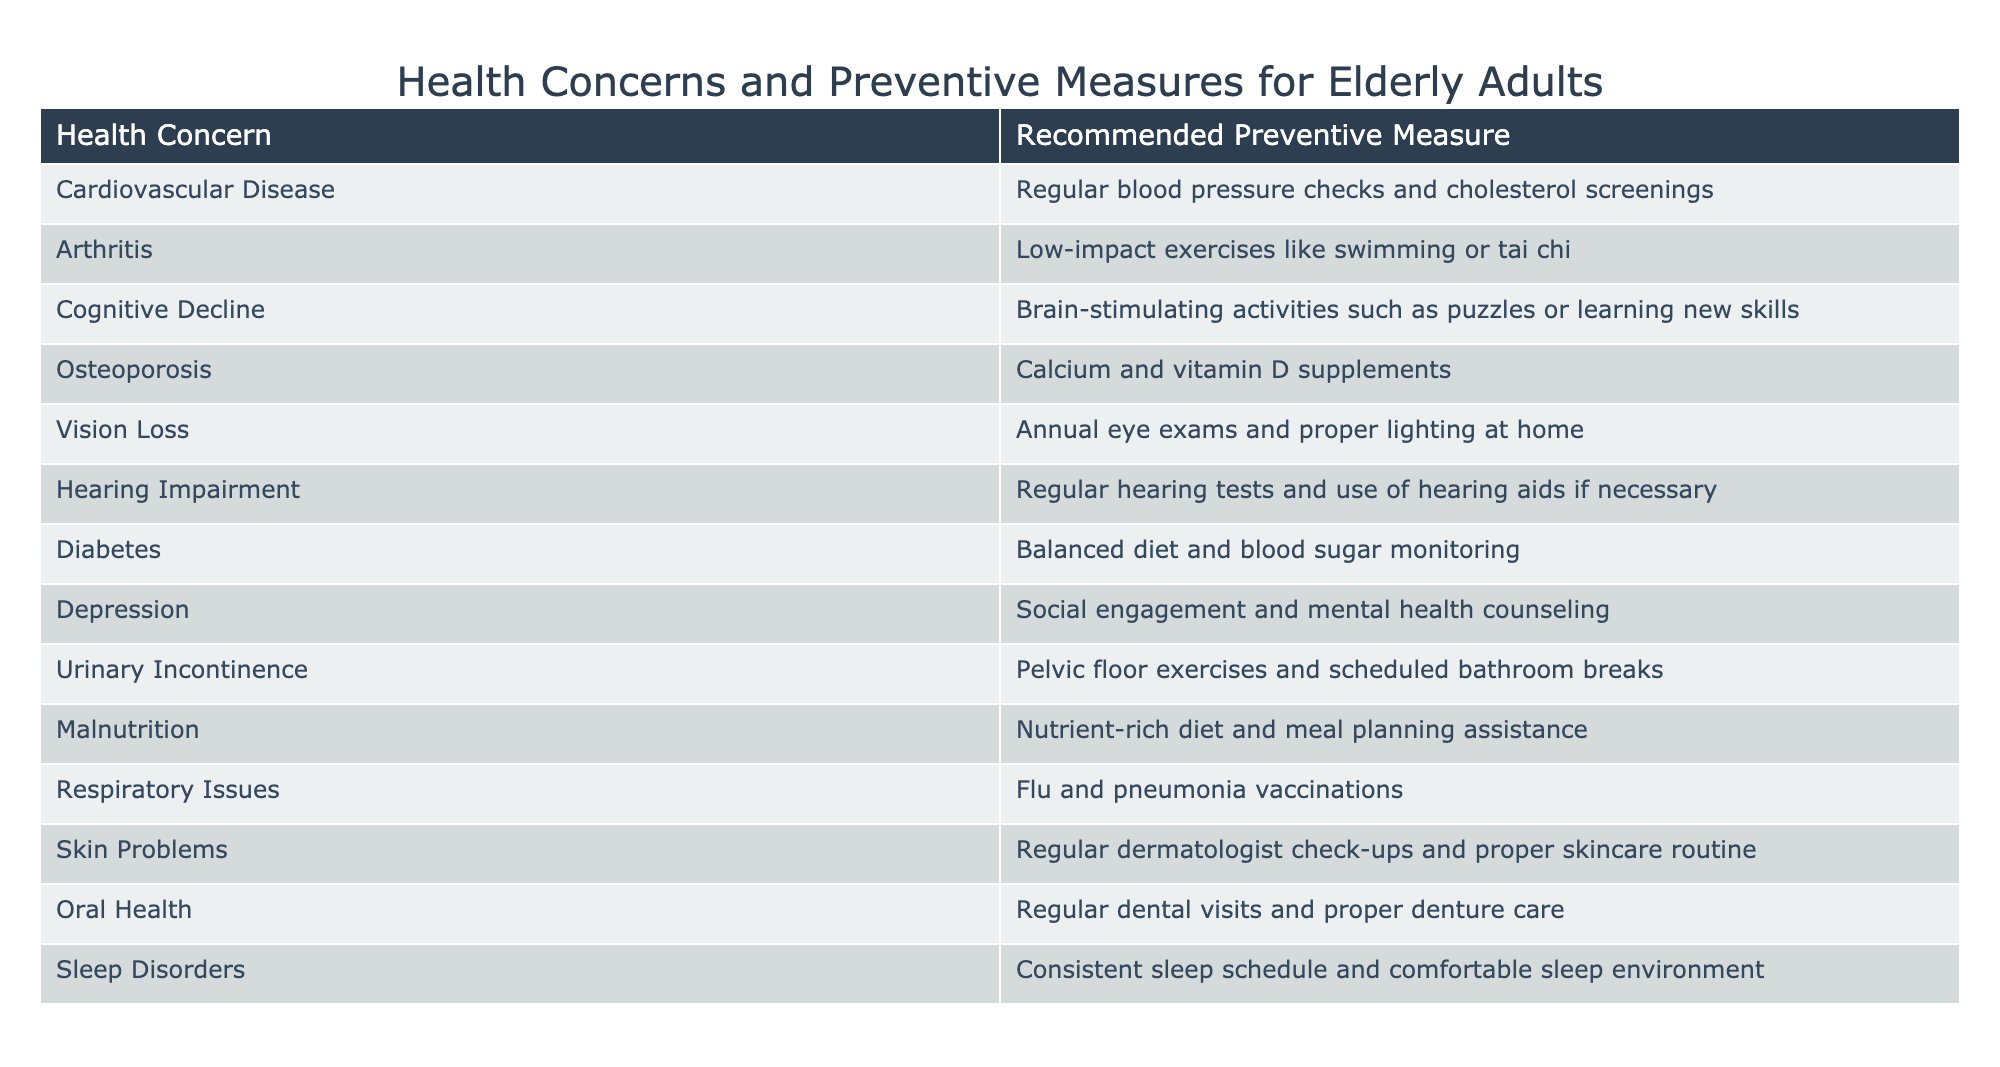What is the recommended preventive measure for arthritis? The table clearly states that the recommended preventive measure for arthritis is "Low-impact exercises like swimming or tai chi". I found this by referencing the specific row corresponding to arthritis in the table.
Answer: Low-impact exercises like swimming or tai chi How many health concerns are listed in the table? To answer this, I simply counted the number of rows in the table that represent health concerns. There are 14 health concerns listed.
Answer: 14 Is social engagement suggested to prevent depression? According to the table, "Social engagement and mental health counseling" is specifically mentioned as a preventive measure for depression. Thus, the answer is yes.
Answer: Yes What are the preventive measures for cardiovascular disease and diabetes combined? For cardiovascular disease, the preventive measure is "Regular blood pressure checks and cholesterol screenings", and for diabetes, it is "Balanced diet and blood sugar monitoring". I retrieved both measures from their respective rows in the table.
Answer: Regular blood pressure checks and cholesterol screenings; Balanced diet and blood sugar monitoring Which health concern has a preventive measure involving exercises? The table mentions that both arthritis ("Low-impact exercises like swimming or tai chi") and urinary incontinence ("Pelvic floor exercises") involve exercises as preventive measures. By identifying and scanning these rows, I confirmed both include exercises.
Answer: Arthritis and urinary incontinence What is the common preventive measure for respiratory issues? The table states that for respiratory issues, the preventive measure is "Flu and pneumonia vaccinations". This information is directly accessible from the respiratory issues row in the table.
Answer: Flu and pneumonia vaccinations Are annual eye exams recommended for preventing vision loss? Yes, the table indicates that "Annual eye exams and proper lighting at home" are the recommended measures to prevent vision loss. Thus, the answer is affirmative.
Answer: Yes Which two health concerns require regular check-ups? Upon reviewing the table, I found that both skin problems and oral health require regular check-ups, specifically "Regular dermatologist check-ups" and "Regular dental visits". I derived this information from their respective rows.
Answer: Skin problems and oral health What preventive measure is suggested for cognitive decline? The table suggests "Brain-stimulating activities such as puzzles or learning new skills" as the preventive measure for cognitive decline. This was found by looking at the cognitive decline row in the table.
Answer: Brain-stimulating activities such as puzzles or learning new skills 